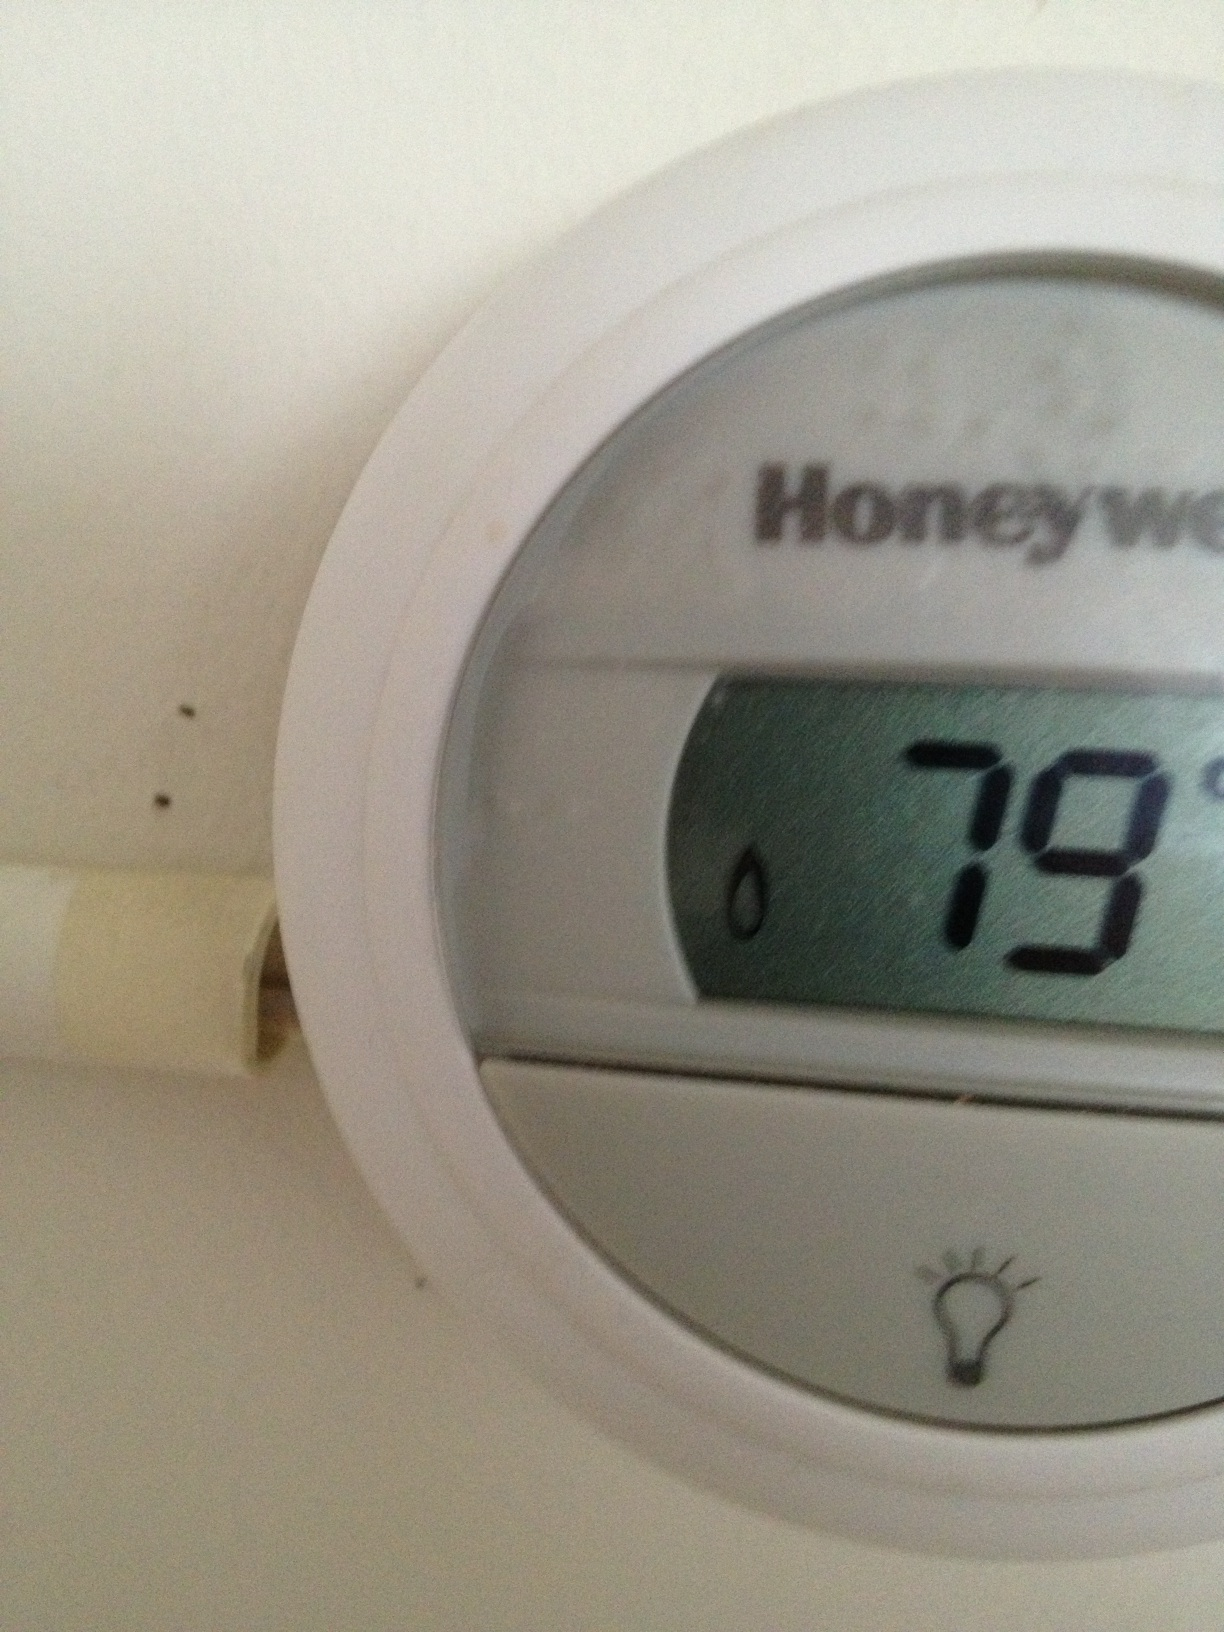What does it say? The thermostat display reads 79 degrees, indicating the current temperature setting or room temperature. 